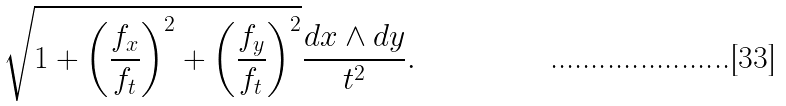Convert formula to latex. <formula><loc_0><loc_0><loc_500><loc_500>\sqrt { 1 + \left ( \frac { f _ { x } } { f _ { t } } \right ) ^ { 2 } + \left ( \frac { f _ { y } } { f _ { t } } \right ) ^ { 2 } } \frac { d x \wedge d y } { t ^ { 2 } } .</formula> 